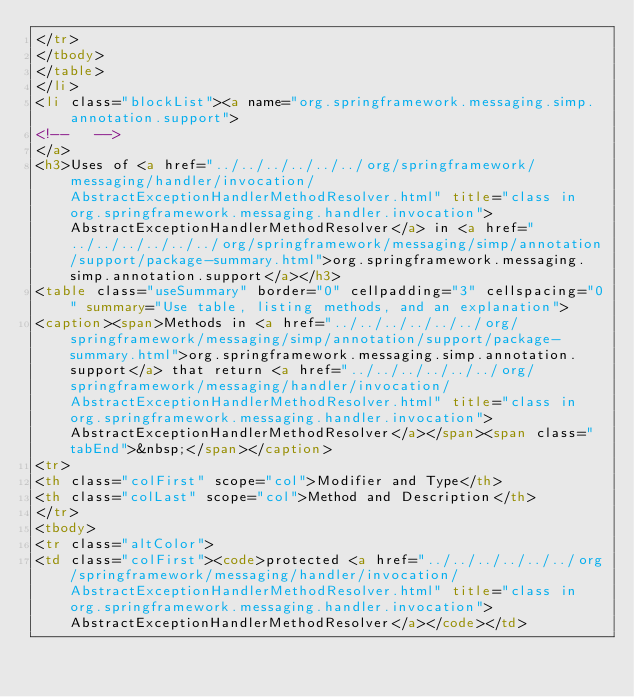Convert code to text. <code><loc_0><loc_0><loc_500><loc_500><_HTML_></tr>
</tbody>
</table>
</li>
<li class="blockList"><a name="org.springframework.messaging.simp.annotation.support">
<!--   -->
</a>
<h3>Uses of <a href="../../../../../../org/springframework/messaging/handler/invocation/AbstractExceptionHandlerMethodResolver.html" title="class in org.springframework.messaging.handler.invocation">AbstractExceptionHandlerMethodResolver</a> in <a href="../../../../../../org/springframework/messaging/simp/annotation/support/package-summary.html">org.springframework.messaging.simp.annotation.support</a></h3>
<table class="useSummary" border="0" cellpadding="3" cellspacing="0" summary="Use table, listing methods, and an explanation">
<caption><span>Methods in <a href="../../../../../../org/springframework/messaging/simp/annotation/support/package-summary.html">org.springframework.messaging.simp.annotation.support</a> that return <a href="../../../../../../org/springframework/messaging/handler/invocation/AbstractExceptionHandlerMethodResolver.html" title="class in org.springframework.messaging.handler.invocation">AbstractExceptionHandlerMethodResolver</a></span><span class="tabEnd">&nbsp;</span></caption>
<tr>
<th class="colFirst" scope="col">Modifier and Type</th>
<th class="colLast" scope="col">Method and Description</th>
</tr>
<tbody>
<tr class="altColor">
<td class="colFirst"><code>protected <a href="../../../../../../org/springframework/messaging/handler/invocation/AbstractExceptionHandlerMethodResolver.html" title="class in org.springframework.messaging.handler.invocation">AbstractExceptionHandlerMethodResolver</a></code></td></code> 